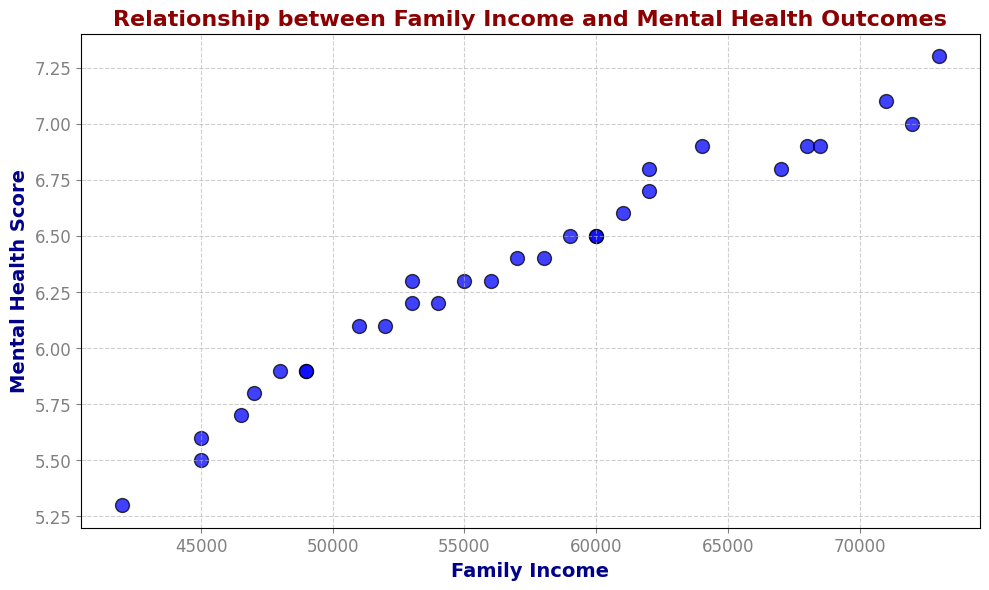What is the general trend observed between family income and mental health outcomes? From the scatter plot, it is observable that as family income increases, the mental health scores also tend to increase. This suggests a positive correlation where higher family income is associated with better mental health outcomes.
Answer: Positive correlation Which data point has the highest mental health score and what is its corresponding family income? By examining the scatter plot, we identify the point with the highest mental health score as 7.3 and trace it to its corresponding family income of $73,000.
Answer: $73,000 Is there a significant outlier in the relationship between family income and mental health outcomes? By looking at the distribution of points, there does not appear to be any significant outlier that is far removed from the general trend of the scatter plot.
Answer: No significant outlier Compare the mental health score of families with income of $45,000 to those with $60,000. Which is higher and by how much? Families with an income of $45,000 have mental health scores of 5.6 and 5.5, while those with $60,000 have scores of 6.5. On average, the scores for $60,000 are about 1 point higher than those for $45,000.
Answer: $60,000 by ~1 point What is the average mental health score for families earning between $50,000 and $60,000? The mental health scores for families earning between $50,000 and $60,000 are: 6.1, 5.9, 6.3, 6.2, 6.4 and 6.5. Summing these scores yields 37.4, and dividing by 6 gives an average score of approximately 6.23.
Answer: 6.23 Compare the mental health score range for family incomes between $40,000 and $50,000 and incomes above $70,000. How do they differ? For $40,000 - $50,000: the scores range between 5.3 and 5.9. For incomes above $70,000: the scores range from 7.0 to 7.3. Incomes above $70,000 show higher and less variable mental health scores compared to the $40,000 - $50,000 range.
Answer: Above $70,000 has higher and less variable scores Is there a clear visual clustering of data points based on family income brackets in the scatter plot? Yes, there is a visual clustering where lower incomes (around $40,000 - $50,000) cluster around lower mental health scores (5-6), while higher incomes (above $60,000) show higher scores (above 6.5).
Answer: Yes What is the most frequent mental health score range observed in the scatter plot? By visually inspecting the scatter plot, most points fall within the mental health score range of 6.0 to 6.9.
Answer: 6.0 - 6.9 